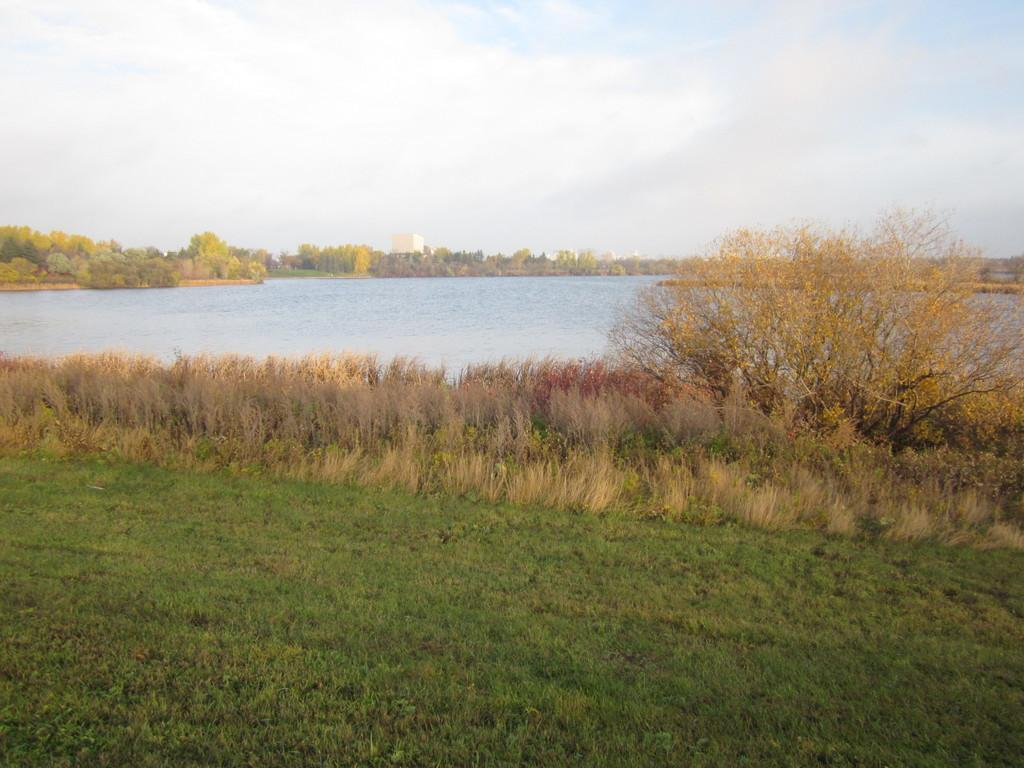What type of ground is visible in the image? There is a greenery ground in the image. Where is the tree located in the image? There is a tree in the right corner of the image. What is in front of the tree? There is water in front of the tree. What can be seen in the distance in the image? There are trees visible in the background of the image. What type of protest is taking place in the bedroom during summer in the image? There is no protest, bedroom, or summer mentioned in the image. The image features a greenery ground, a tree, water, and trees in the background. 